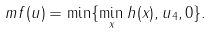<formula> <loc_0><loc_0><loc_500><loc_500>\ m f ( u ) = \min \{ \min _ { x } h ( x ) , u _ { 4 } , 0 \} .</formula> 